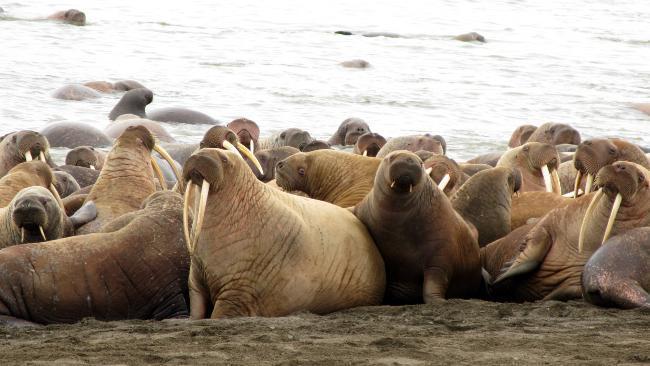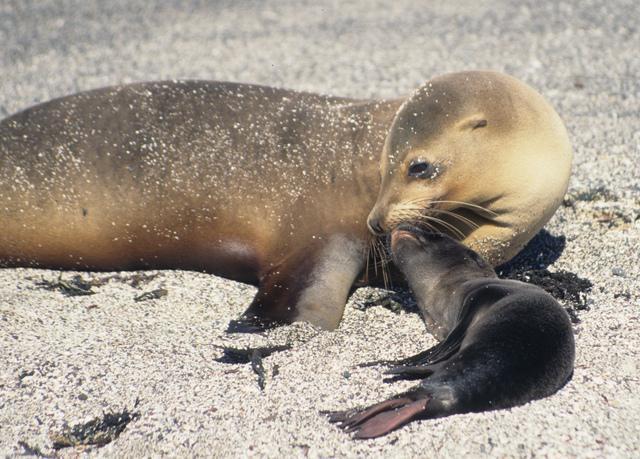The first image is the image on the left, the second image is the image on the right. For the images shown, is this caption "An image shows exactly one dark baby seal in contact with a larger, paler seal." true? Answer yes or no. Yes. The first image is the image on the left, the second image is the image on the right. For the images displayed, is the sentence "Two seals are bonding in one of the images." factually correct? Answer yes or no. Yes. 